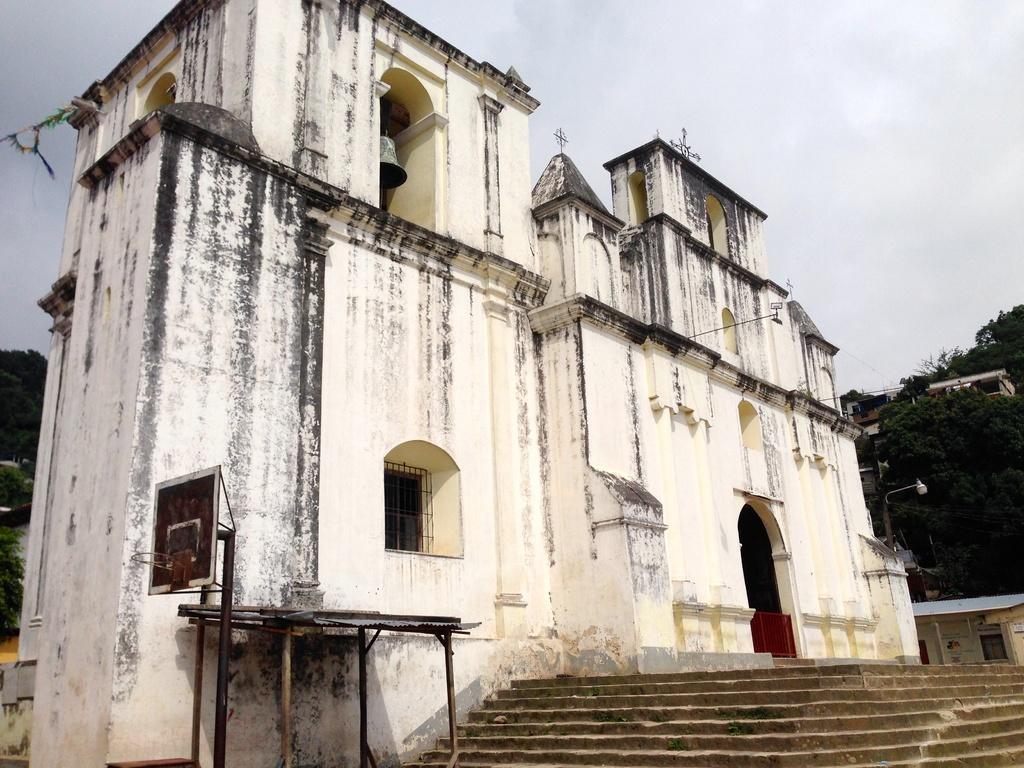In one or two sentences, can you explain what this image depicts? In this picture we can see few buildings, trees, poles and a bell, on the left side of the image we can see a basketball net. 